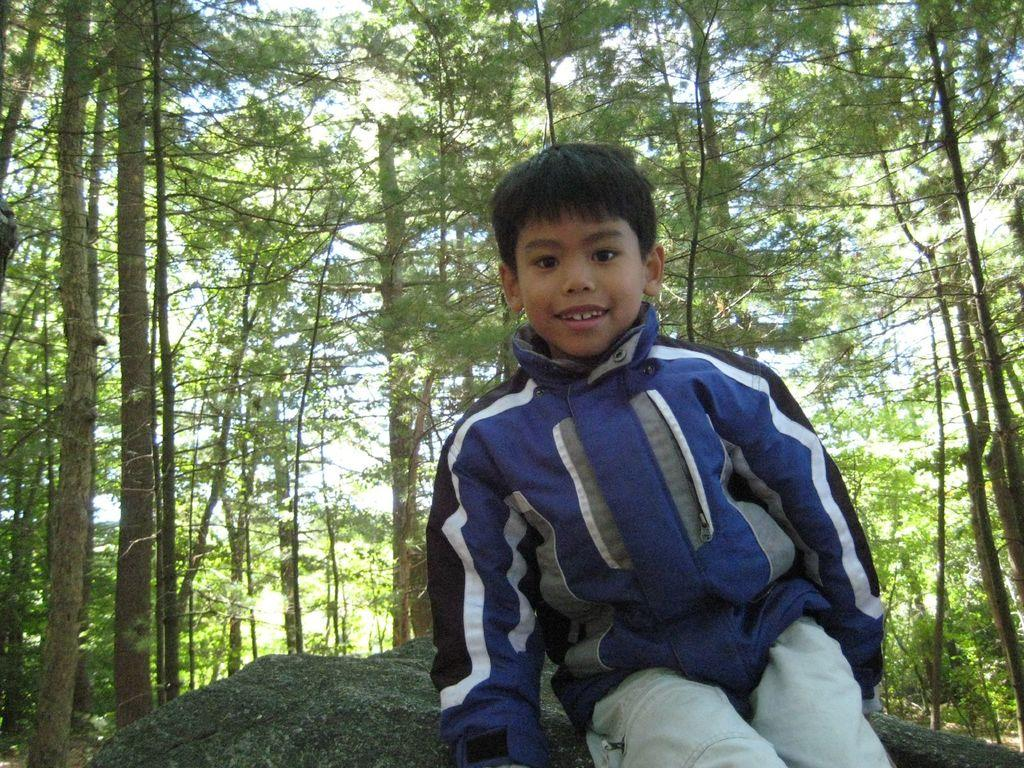Who is the main subject in the image? There is a boy in the image. What is the boy doing in the image? The boy is sitting on a stone surface. What is the boy wearing in the image? The boy is wearing a blue jacket. What is the boy's facial expression in the image? The boy is smiling. What can be seen in the background of the image? There are trees with tall branches behind the boy. What type of toy is the boy holding in the image? There is no toy visible in the image; the boy is not holding anything. 